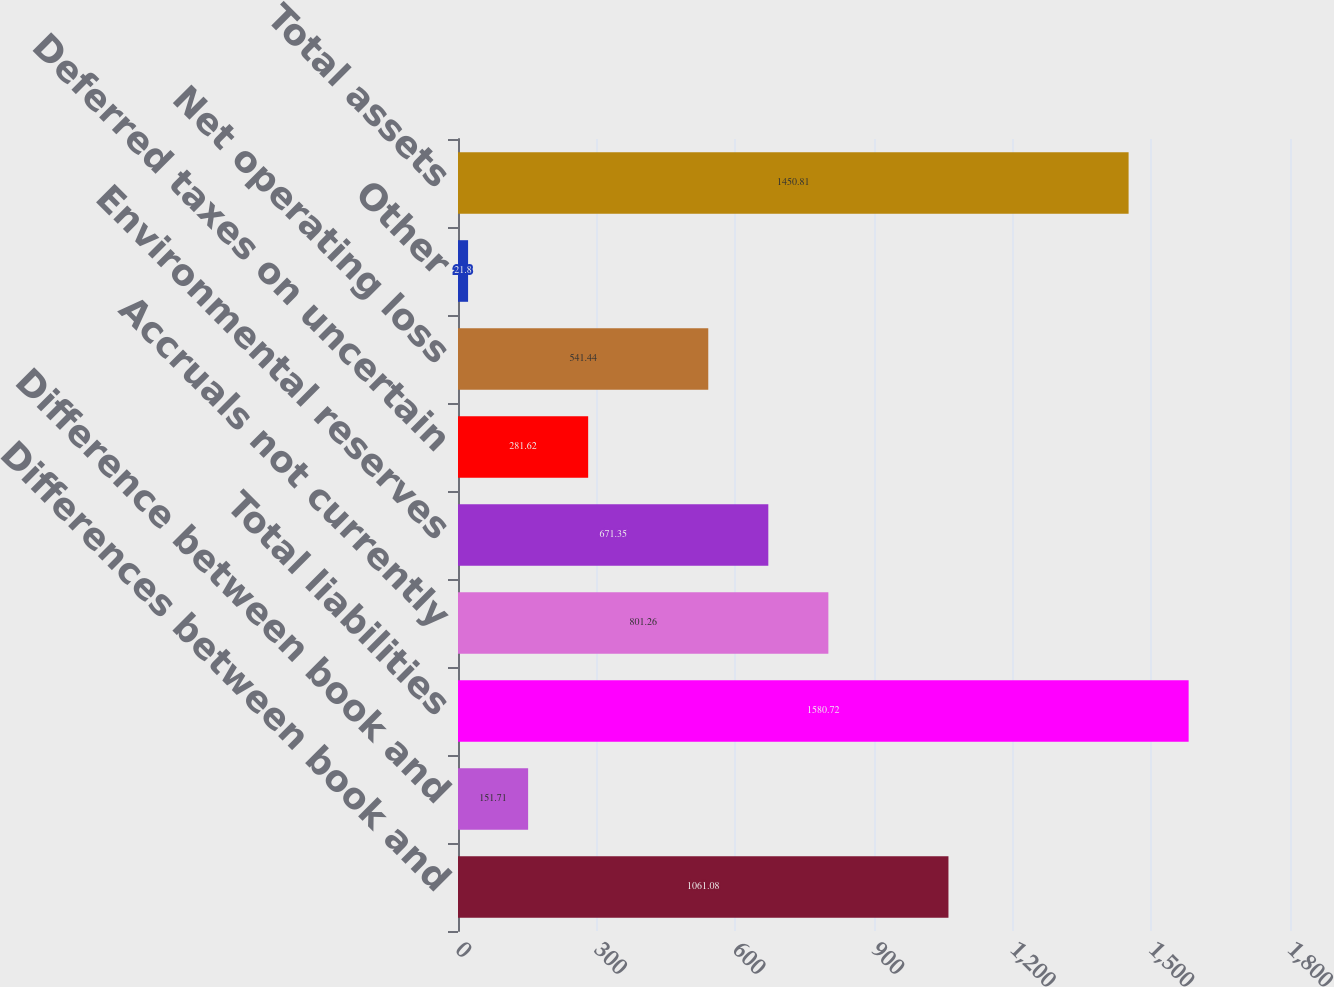<chart> <loc_0><loc_0><loc_500><loc_500><bar_chart><fcel>Differences between book and<fcel>Difference between book and<fcel>Total liabilities<fcel>Accruals not currently<fcel>Environmental reserves<fcel>Deferred taxes on uncertain<fcel>Net operating loss<fcel>Other<fcel>Total assets<nl><fcel>1061.08<fcel>151.71<fcel>1580.72<fcel>801.26<fcel>671.35<fcel>281.62<fcel>541.44<fcel>21.8<fcel>1450.81<nl></chart> 